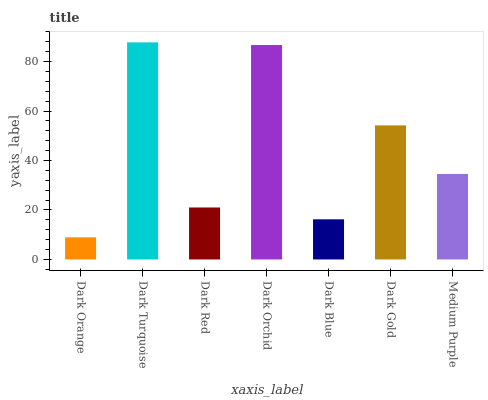Is Dark Red the minimum?
Answer yes or no. No. Is Dark Red the maximum?
Answer yes or no. No. Is Dark Turquoise greater than Dark Red?
Answer yes or no. Yes. Is Dark Red less than Dark Turquoise?
Answer yes or no. Yes. Is Dark Red greater than Dark Turquoise?
Answer yes or no. No. Is Dark Turquoise less than Dark Red?
Answer yes or no. No. Is Medium Purple the high median?
Answer yes or no. Yes. Is Medium Purple the low median?
Answer yes or no. Yes. Is Dark Turquoise the high median?
Answer yes or no. No. Is Dark Orange the low median?
Answer yes or no. No. 